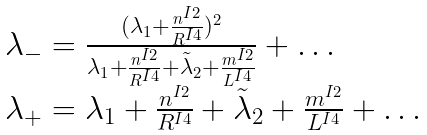<formula> <loc_0><loc_0><loc_500><loc_500>\begin{array} { l } \lambda _ { - } = \frac { { ( \lambda _ { 1 } + \frac { { n ^ { I 2 } } } { { R ^ { I 4 } } } ) ^ { 2 } } } { { \lambda _ { 1 } + \frac { { n ^ { I 2 } } } { { R ^ { I 4 } } } + \tilde { \lambda } _ { 2 } + \frac { { m ^ { I 2 } } } { { L ^ { I 4 } } } } } + \dots \\ \lambda _ { + } = \lambda _ { 1 } + \frac { { n ^ { I 2 } } } { { R ^ { I 4 } } } + \tilde { \lambda } _ { 2 } + \frac { { m ^ { I 2 } } } { { L ^ { I 4 } } } + \dots \\ \end{array}</formula> 